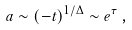<formula> <loc_0><loc_0><loc_500><loc_500>a \sim ( - t ) ^ { 1 / \Delta } \sim e ^ { \tau } \, ,</formula> 